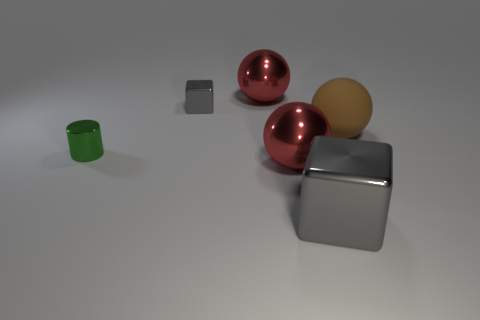What number of balls are big gray objects or large brown things?
Offer a terse response. 1. Does the brown sphere have the same material as the large gray object?
Offer a very short reply. No. There is another gray shiny thing that is the same shape as the tiny gray thing; what is its size?
Provide a succinct answer. Large. The thing that is to the left of the large block and in front of the tiny green cylinder is made of what material?
Your answer should be very brief. Metal. Are there the same number of tiny things that are behind the tiny gray shiny thing and small shiny objects?
Ensure brevity in your answer.  No. What number of objects are either metallic things that are in front of the tiny block or big brown rubber things?
Give a very brief answer. 4. There is a large shiny ball in front of the green shiny thing; is it the same color as the big matte object?
Keep it short and to the point. No. There is a brown matte thing on the right side of the big metallic cube; what is its size?
Ensure brevity in your answer.  Large. There is a gray thing that is in front of the big metallic sphere in front of the cylinder; what shape is it?
Provide a short and direct response. Cube. The big object that is the same shape as the tiny gray metal object is what color?
Your response must be concise. Gray. 